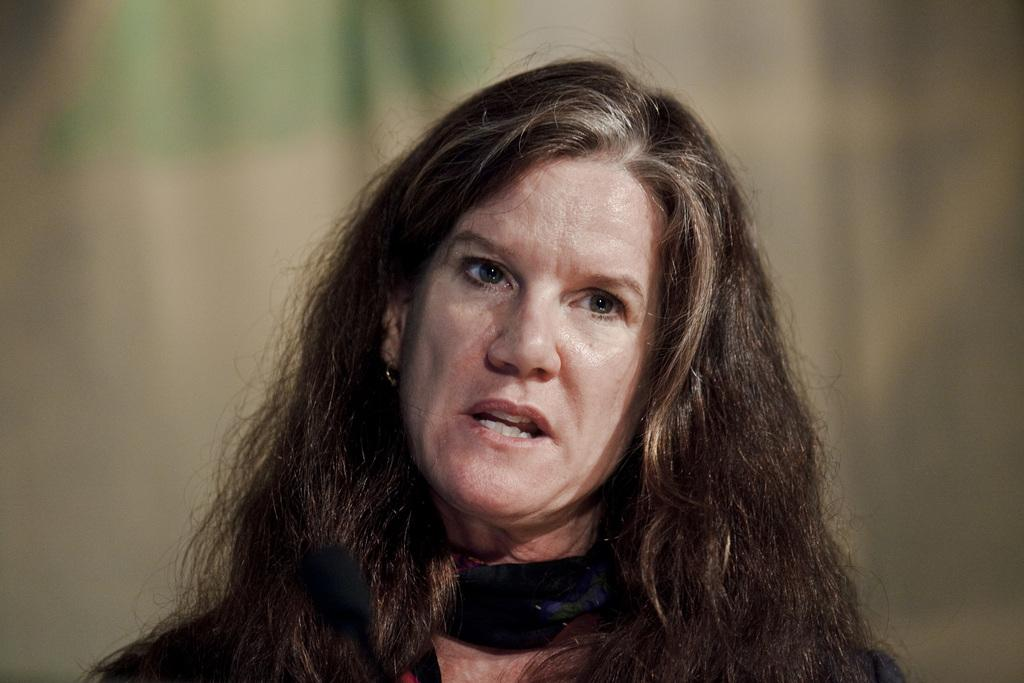Who is the main subject in the image? There is a woman in the image. What is the woman wearing? The woman is wearing a black dress. Can you describe the background of the image? The background of the image is blurred. What type of instrument is the woman playing in the image? There is no instrument present in the image; the woman is not playing any instrument. What color is the woman's underwear in the image? There is no information about the woman's underwear in the image, as it is not visible. What kind of cheese is visible on the table in the image? There is no cheese present in the image; the image only features a woman wearing a black dress with a blurred background. 